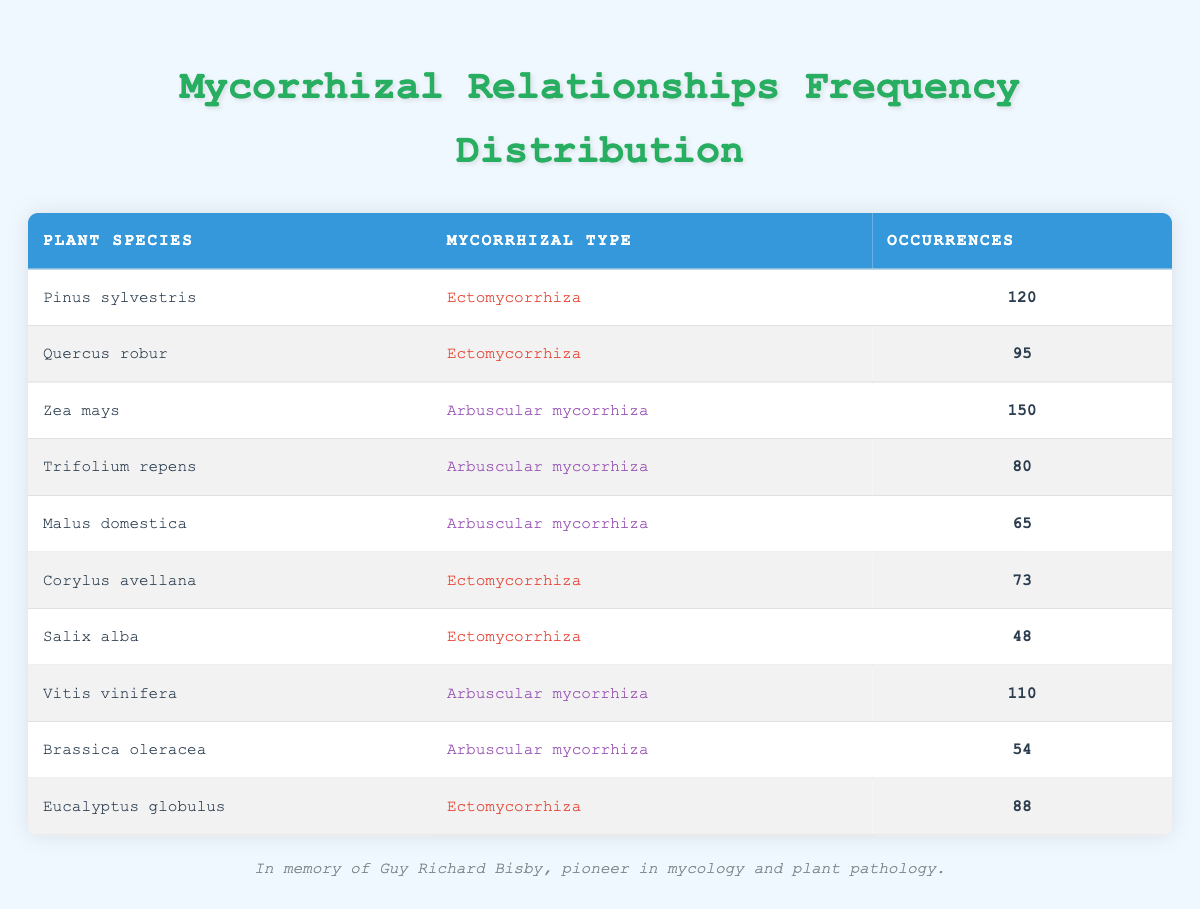What is the occurrence count for Zea mays? The table shows a specific entry for Zea mays under the occurrences column, which is listed as 150.
Answer: 150 Which plant species has the lowest occurrences? By inspecting the occurrences column, Salix alba has the lowest value listed at 48.
Answer: Salix alba How many plant species have Ectomycorrhiza as their mycorrhizal type? To find this, count the entries in the table where the mycorrhizal type is Ectomycorrhiza: Pinus sylvestris, Quercus robur, Corylus avellana, Salix alba, and Eucalyptus globulus, which totals to 5 species.
Answer: 5 What is the sum of occurrences for Arbuscular mycorrhiza plant species? The occurrences for the Arbuscular mycorrhiza species (Zea mays, Trifolium repens, Malus domestica, Vitis vinifera, and Brassica oleracea) are 150, 80, 65, 110, and 54, respectively. Summing these gives 150 + 80 + 65 + 110 + 54 = 459.
Answer: 459 Is Eucalyptus globulus an Arbuscular mycorrhiza plant species? Looking at the mycorrhizal type for Eucalyptus globulus in the table, it is labeled as Ectomycorrhiza, indicating that it is not an Arbuscular mycorrhiza species.
Answer: No What is the average occurrence count for Ectomycorrhiza species? The Ectomycorrhiza species listed are Pinus sylvestris (120), Quercus robur (95), Corylus avellana (73), Salix alba (48), and Eucalyptus globulus (88). Calculating the average: (120 + 95 + 73 + 48 + 88) / 5 = 424 / 5 = 84.8.
Answer: 84.8 Which mycorrhizal type has a higher total occurrence, Ectomycorrhiza or Arbuscular mycorrhiza? Calculate the total occurrences for both types: Ectomycorrhiza - 120 + 95 + 73 + 48 + 88 = 424; Arbuscular mycorrhiza - 150 + 80 + 65 + 110 + 54 = 459. Since 459 (Arbuscular) is greater than 424 (Ectomycorrhiza), Arbuscular mycorrhiza has a higher total occurrence.
Answer: Arbuscular mycorrhiza Are there more plant species listed under Arbuscular mycorrhiza or Ectomycorrhiza? Counting entries shows 5 species under Arbuscular mycorrhiza (Zea mays, Trifolium repens, Malus domestica, Vitis vinifera, Brassica oleracea) and 5 species under Ectomycorrhiza (Pinus sylvestris, Quercus robur, Corylus avellana, Salix alba, Eucalyptus globulus). Since both totals are equal, the answer is no.
Answer: No 